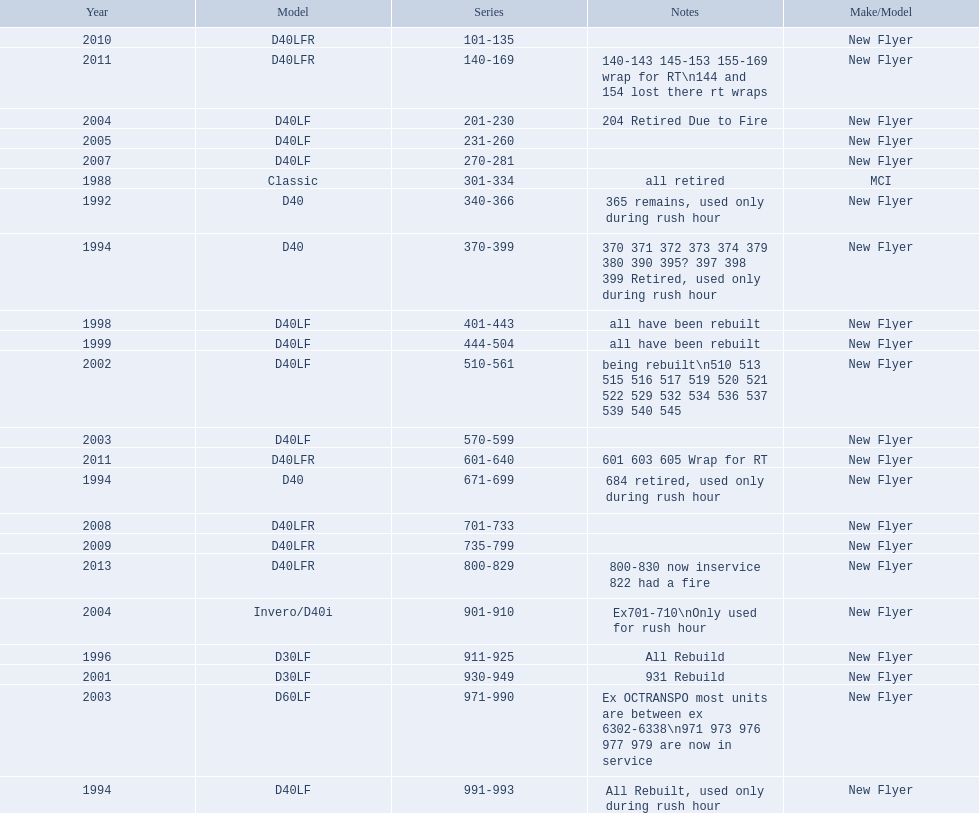What are all the series of buses? 101-135, 140-169, 201-230, 231-260, 270-281, 301-334, 340-366, 370-399, 401-443, 444-504, 510-561, 570-599, 601-640, 671-699, 701-733, 735-799, 800-829, 901-910, 911-925, 930-949, 971-990, 991-993. Which are the newest? 800-829. 